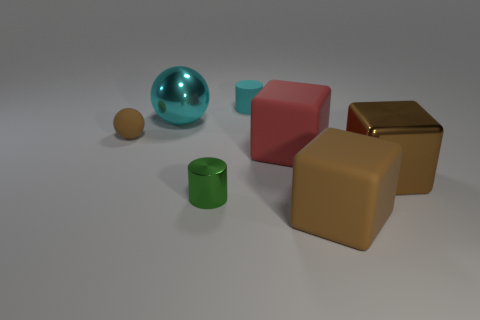There is a brown metallic cube; is it the same size as the cylinder that is behind the small brown rubber object?
Your answer should be compact. No. Are there any large objects of the same color as the large shiny ball?
Your answer should be very brief. No. Do the green object and the small ball have the same material?
Provide a succinct answer. No. How many small spheres are in front of the large red object?
Ensure brevity in your answer.  0. What is the material of the large thing that is both behind the metallic block and in front of the cyan metal thing?
Your answer should be compact. Rubber. What number of objects have the same size as the green cylinder?
Provide a succinct answer. 2. There is a large metallic object that is to the left of the big red rubber cube that is right of the small green shiny cylinder; what color is it?
Your answer should be very brief. Cyan. Is there a cyan object?
Keep it short and to the point. Yes. Is the shape of the large cyan metallic thing the same as the red matte thing?
Give a very brief answer. No. What is the size of the other block that is the same color as the large metallic block?
Keep it short and to the point. Large. 